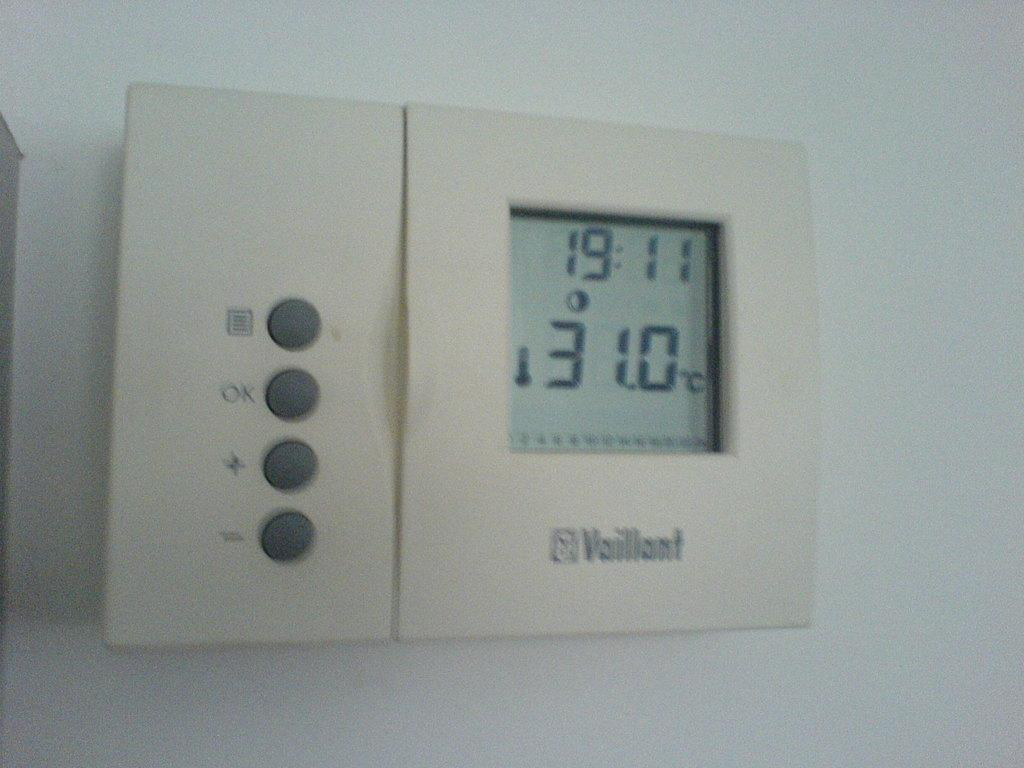<image>
Create a compact narrative representing the image presented. thermometer is displayed time is 19:11 and temp is 31.0 